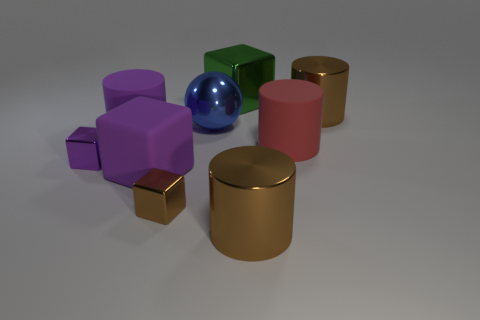Add 1 brown rubber objects. How many objects exist? 10 Subtract all balls. How many objects are left? 8 Add 6 brown metallic blocks. How many brown metallic blocks exist? 7 Subtract 0 green spheres. How many objects are left? 9 Subtract all small shiny blocks. Subtract all small purple blocks. How many objects are left? 6 Add 4 big brown shiny cylinders. How many big brown shiny cylinders are left? 6 